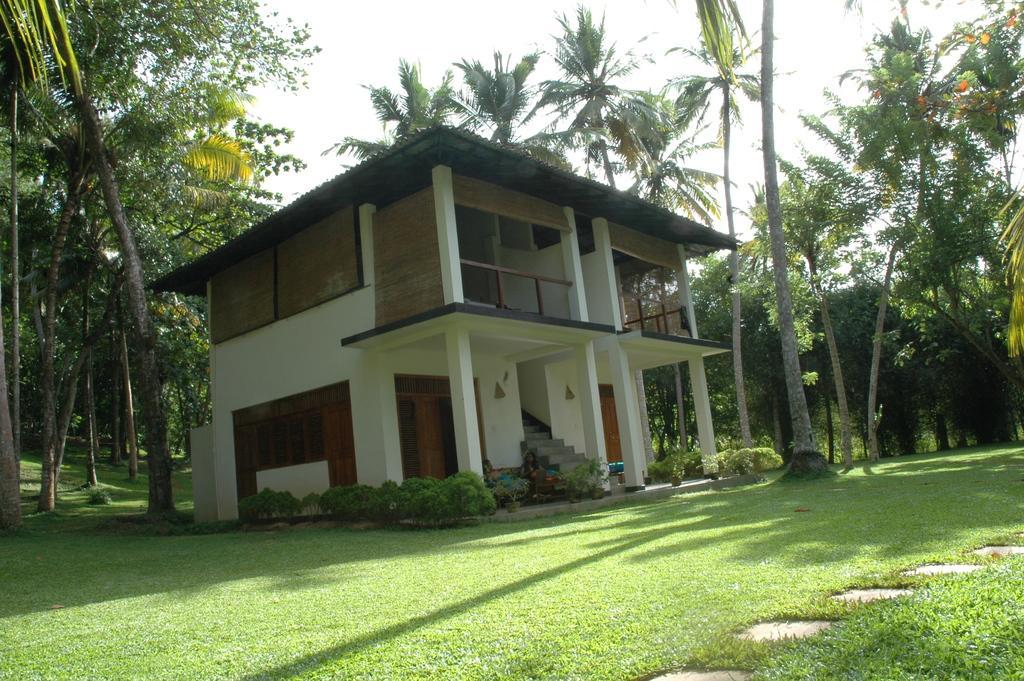In one or two sentences, can you explain what this image depicts? In this image I can see grass, stairs, a white colour building, shadows and number of trees. 